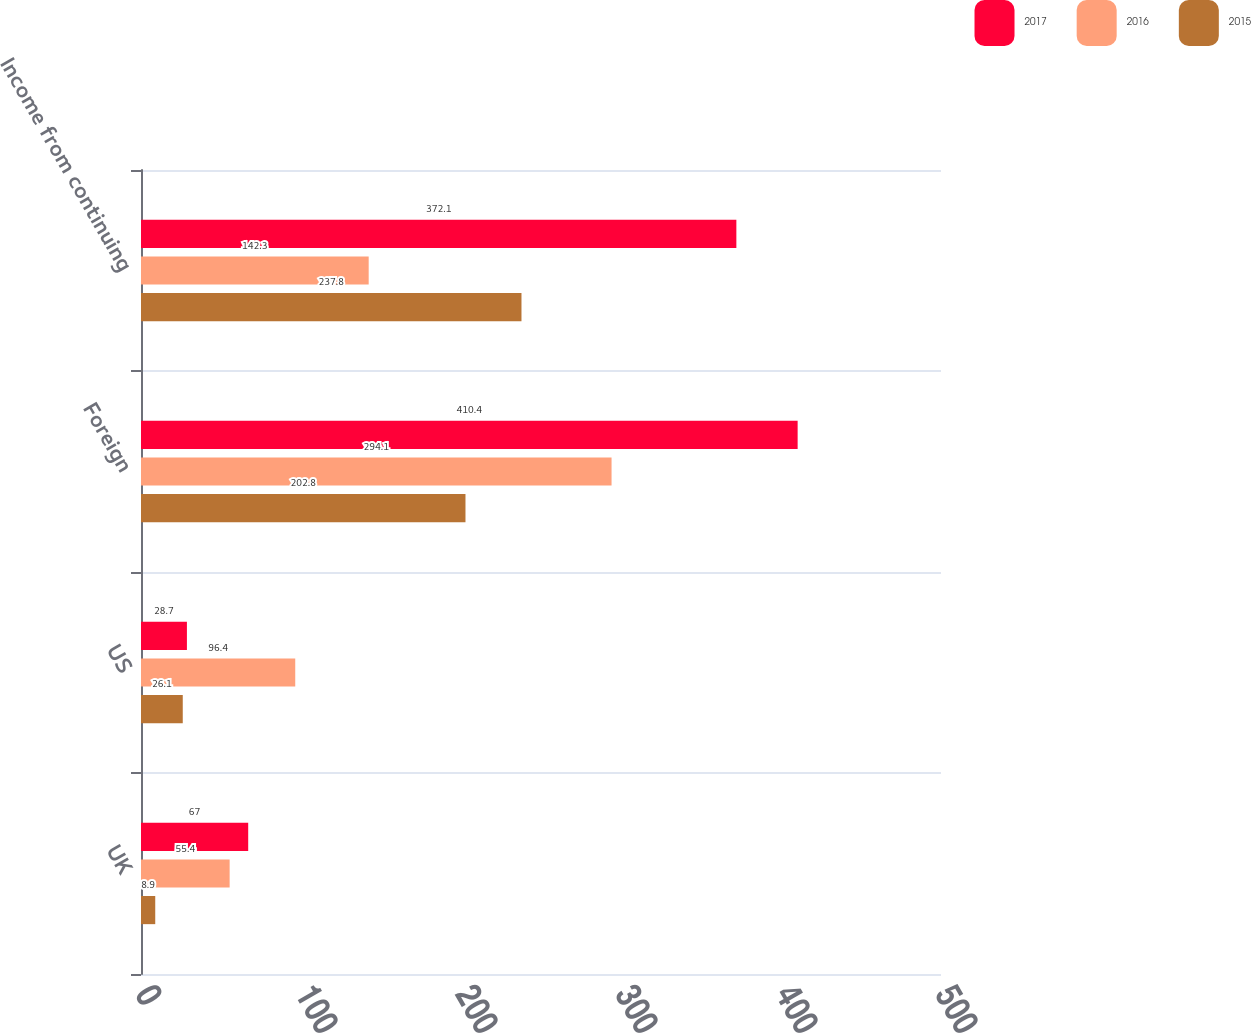Convert chart to OTSL. <chart><loc_0><loc_0><loc_500><loc_500><stacked_bar_chart><ecel><fcel>UK<fcel>US<fcel>Foreign<fcel>Income from continuing<nl><fcel>2017<fcel>67<fcel>28.7<fcel>410.4<fcel>372.1<nl><fcel>2016<fcel>55.4<fcel>96.4<fcel>294.1<fcel>142.3<nl><fcel>2015<fcel>8.9<fcel>26.1<fcel>202.8<fcel>237.8<nl></chart> 